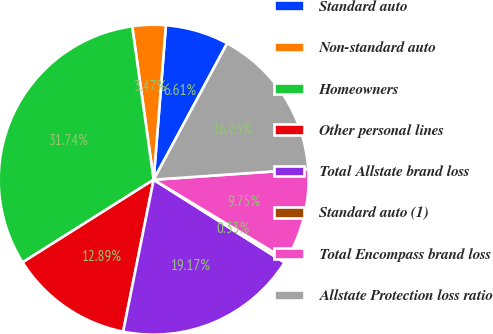Convert chart to OTSL. <chart><loc_0><loc_0><loc_500><loc_500><pie_chart><fcel>Standard auto<fcel>Non-standard auto<fcel>Homeowners<fcel>Other personal lines<fcel>Total Allstate brand loss<fcel>Standard auto (1)<fcel>Total Encompass brand loss<fcel>Allstate Protection loss ratio<nl><fcel>6.61%<fcel>3.47%<fcel>31.74%<fcel>12.89%<fcel>19.17%<fcel>0.33%<fcel>9.75%<fcel>16.03%<nl></chart> 